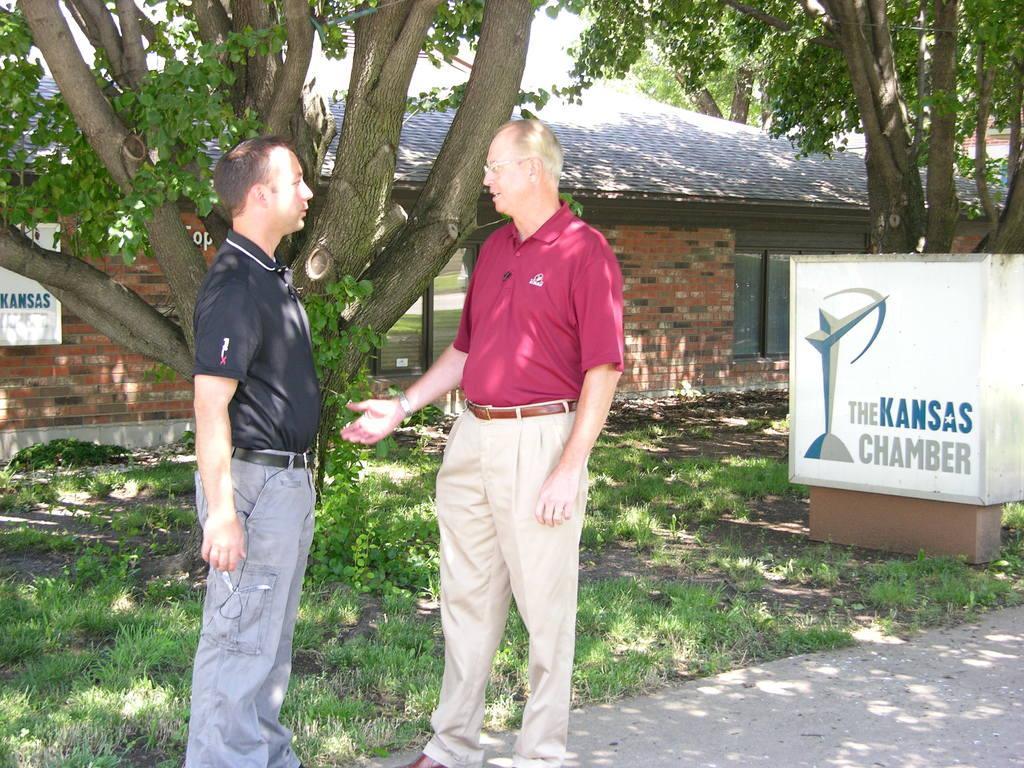Could you give a brief overview of what you see in this image? In this image there are two persons standing in middle of this image and there is a house in the background. There are some trees on the left side of this image and right side of this image as well. There is some grass in the bottom of this image. 